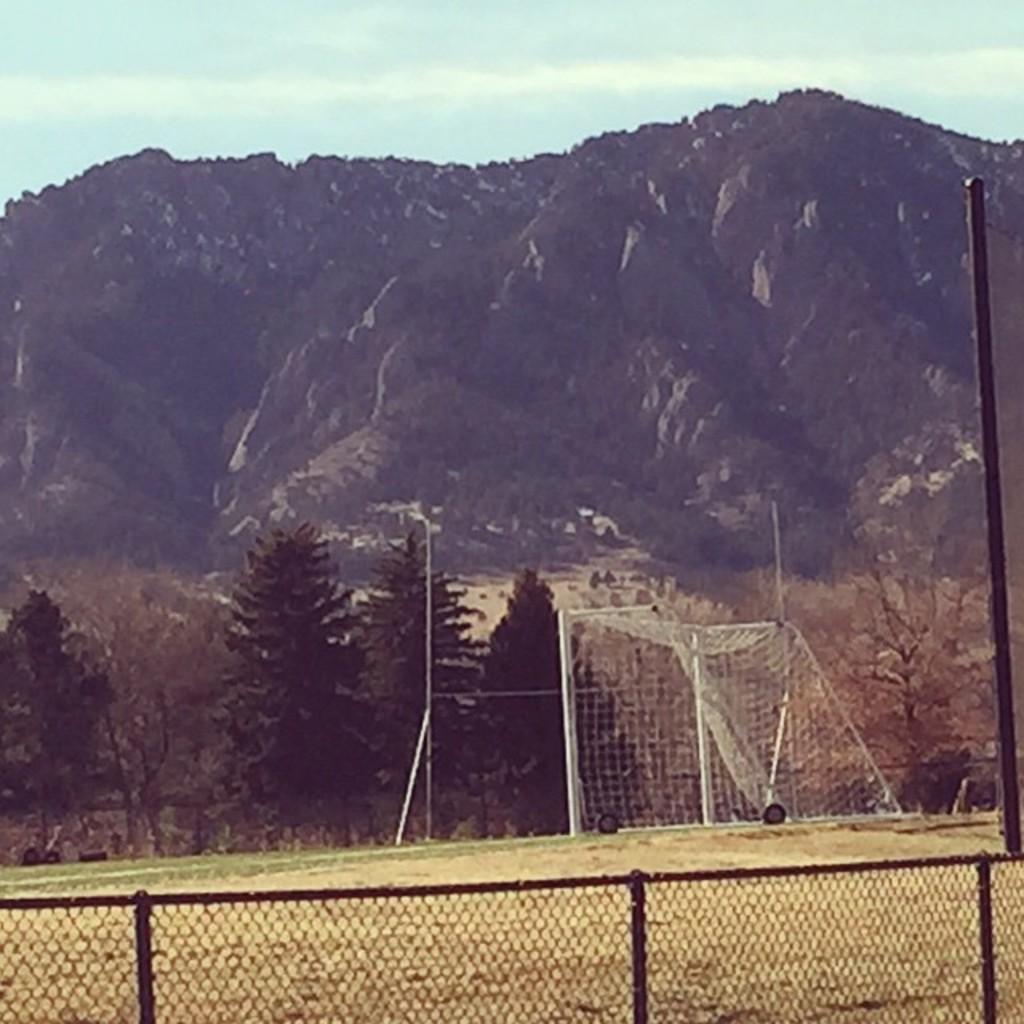Describe this image in one or two sentences. At the bottom of the picture, we see a fence. Behind that, we see grass and a net. On the right side, we see a pole. There are trees and hills in the background. At the top of the picture, we see the sky. 